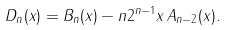<formula> <loc_0><loc_0><loc_500><loc_500>D _ { n } ( x ) = B _ { n } ( x ) - n 2 ^ { n - 1 } x \, A _ { n - 2 } ( x ) .</formula> 